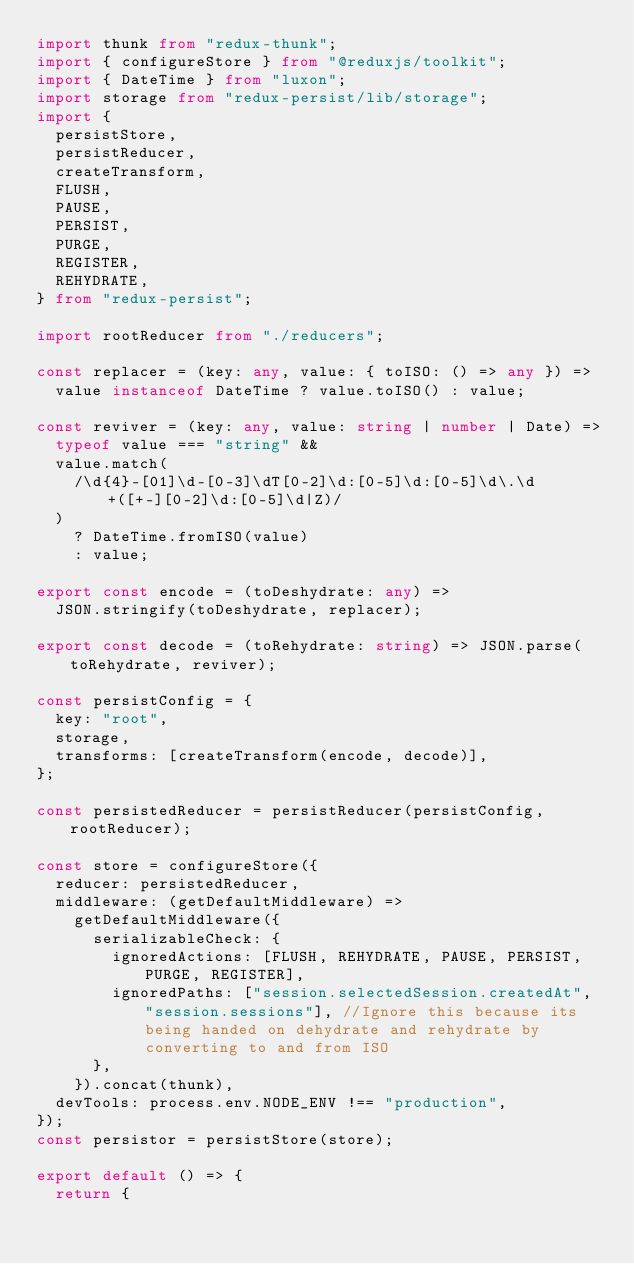<code> <loc_0><loc_0><loc_500><loc_500><_TypeScript_>import thunk from "redux-thunk";
import { configureStore } from "@reduxjs/toolkit";
import { DateTime } from "luxon";
import storage from "redux-persist/lib/storage";
import {
  persistStore,
  persistReducer,
  createTransform,
  FLUSH,
  PAUSE,
  PERSIST,
  PURGE,
  REGISTER,
  REHYDRATE,
} from "redux-persist";

import rootReducer from "./reducers";

const replacer = (key: any, value: { toISO: () => any }) =>
  value instanceof DateTime ? value.toISO() : value;

const reviver = (key: any, value: string | number | Date) =>
  typeof value === "string" &&
  value.match(
    /\d{4}-[01]\d-[0-3]\dT[0-2]\d:[0-5]\d:[0-5]\d\.\d+([+-][0-2]\d:[0-5]\d|Z)/
  )
    ? DateTime.fromISO(value)
    : value;

export const encode = (toDeshydrate: any) =>
  JSON.stringify(toDeshydrate, replacer);

export const decode = (toRehydrate: string) => JSON.parse(toRehydrate, reviver);

const persistConfig = {
  key: "root",
  storage,
  transforms: [createTransform(encode, decode)],
};

const persistedReducer = persistReducer(persistConfig, rootReducer);

const store = configureStore({
  reducer: persistedReducer,
  middleware: (getDefaultMiddleware) =>
    getDefaultMiddleware({
      serializableCheck: {
        ignoredActions: [FLUSH, REHYDRATE, PAUSE, PERSIST, PURGE, REGISTER],
        ignoredPaths: ["session.selectedSession.createdAt", "session.sessions"], //Ignore this because its being handed on dehydrate and rehydrate by converting to and from ISO
      },
    }).concat(thunk),
  devTools: process.env.NODE_ENV !== "production",
});
const persistor = persistStore(store);

export default () => {
  return {</code> 